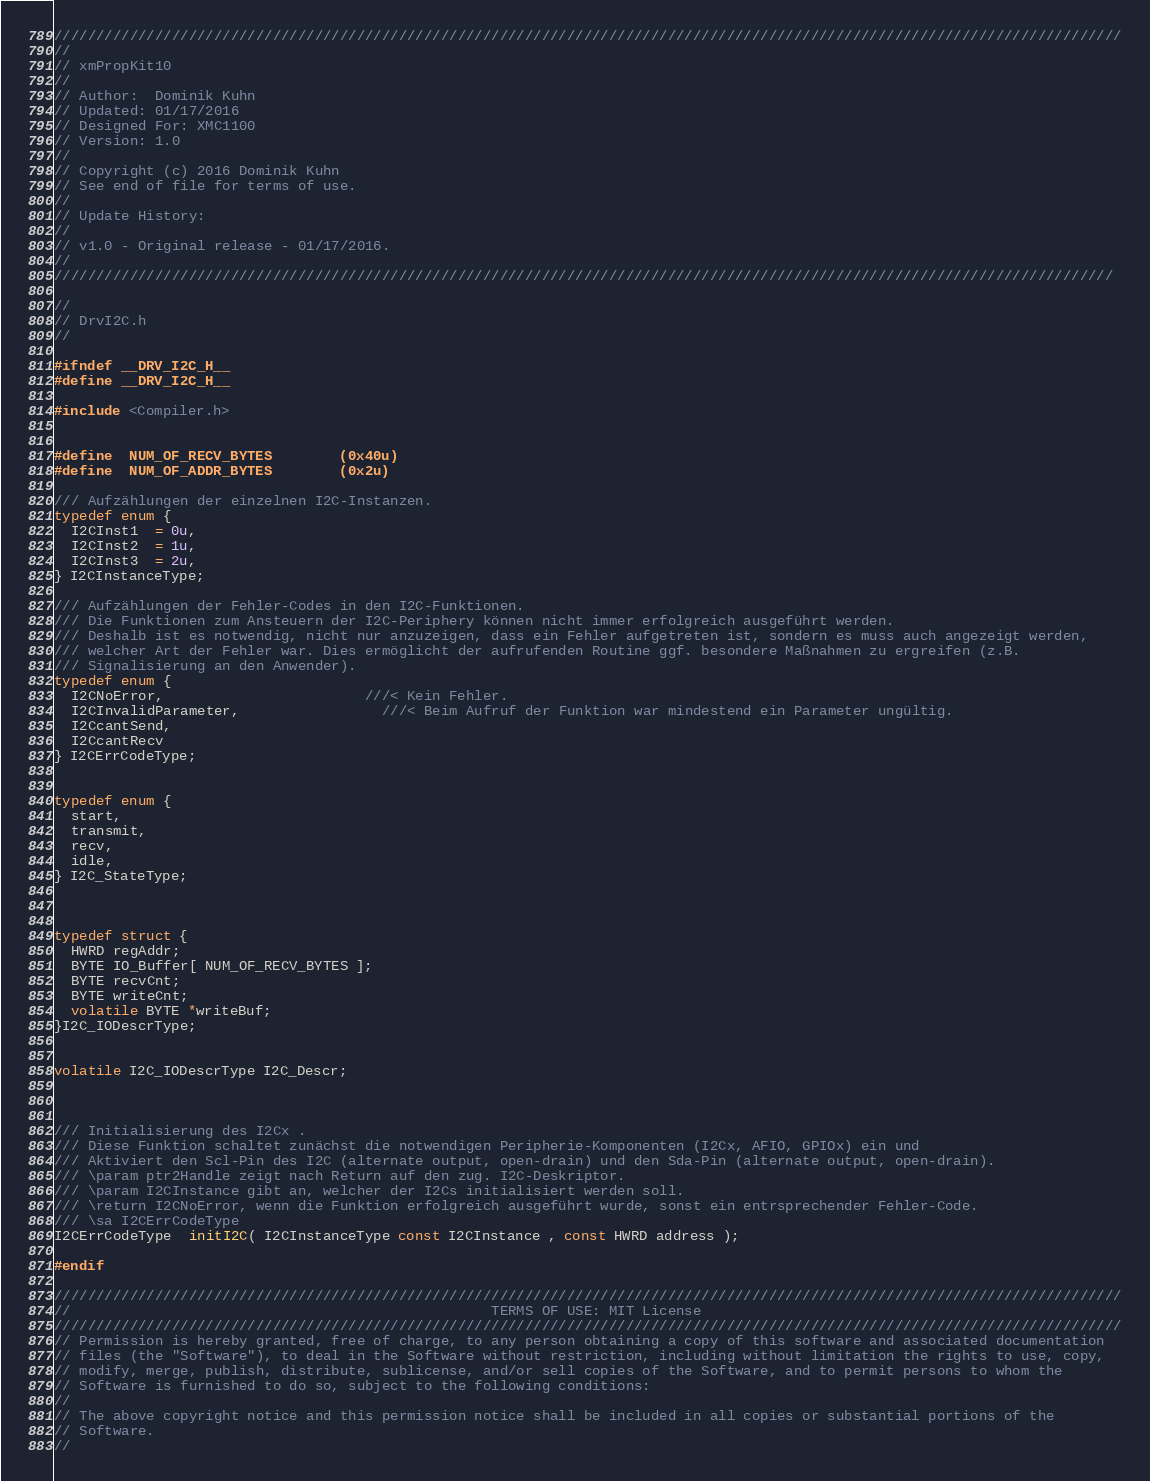<code> <loc_0><loc_0><loc_500><loc_500><_C_>///////////////////////////////////////////////////////////////////////////////////////////////////////////////////////////////
//
// xmPropKit10
//
// Author:  Dominik Kuhn
// Updated: 01/17/2016
// Designed For: XMC1100
// Version: 1.0
//
// Copyright (c) 2016 Dominik Kuhn
// See end of file for terms of use.
//
// Update History:
//
// v1.0 - Original release - 01/17/2016.
//
//////////////////////////////////////////////////////////////////////////////////////////////////////////////////////////////

//
// DrvI2C.h
//

#ifndef __DRV_I2C_H__
#define __DRV_I2C_H__

#include <Compiler.h>


#define  NUM_OF_RECV_BYTES        (0x40u)
#define  NUM_OF_ADDR_BYTES        (0x2u)

/// Aufzählungen der einzelnen I2C-Instanzen.
typedef enum {
  I2CInst1  = 0u,
  I2CInst2  = 1u,
  I2CInst3  = 2u,
} I2CInstanceType;

/// Aufzählungen der Fehler-Codes in den I2C-Funktionen.
/// Die Funktionen zum Ansteuern der I2C-Periphery können nicht immer erfolgreich ausgeführt werden. 
/// Deshalb ist es notwendig, nicht nur anzuzeigen, dass ein Fehler aufgetreten ist, sondern es muss auch angezeigt werden,
/// welcher Art der Fehler war. Dies ermöglicht der aufrufenden Routine ggf. besondere Maßnahmen zu ergreifen (z.B. 
/// Signalisierung an den Anwender).
typedef enum {
  I2CNoError,                        ///< Kein Fehler.
  I2CInvalidParameter,	             ///< Beim Aufruf der Funktion war mindestend ein Parameter ungültig.
  I2CcantSend,
  I2CcantRecv
} I2CErrCodeType;


typedef enum {
  start,
  transmit,
  recv,
  idle,
} I2C_StateType;



typedef struct {
  HWRD regAddr;
  BYTE IO_Buffer[ NUM_OF_RECV_BYTES ];
  BYTE recvCnt;
  BYTE writeCnt;  
  volatile BYTE *writeBuf;
}I2C_IODescrType;


volatile I2C_IODescrType I2C_Descr;



/// Initialisierung des I2Cx .
/// Diese Funktion schaltet zunächst die notwendigen Peripherie-Komponenten (I2Cx, AFIO, GPIOx) ein und
/// Aktiviert den Scl-Pin des I2C (alternate output, open-drain) und den Sda-Pin (alternate output, open-drain).
/// \param ptr2Handle zeigt nach Return auf den zug. I2C-Deskriptor.
/// \param I2CInstance gibt an, welcher der I2Cs initialisiert werden soll.
/// \return I2CNoError, wenn die Funktion erfolgreich ausgeführt wurde, sonst ein entrsprechender Fehler-Code.
/// \sa I2CErrCodeType
I2CErrCodeType  initI2C( I2CInstanceType const I2CInstance , const HWRD address );

#endif

///////////////////////////////////////////////////////////////////////////////////////////////////////////////////////////////
//                                                  TERMS OF USE: MIT License
///////////////////////////////////////////////////////////////////////////////////////////////////////////////////////////////
// Permission is hereby granted, free of charge, to any person obtaining a copy of this software and associated documentation
// files (the "Software"), to deal in the Software without restriction, including without limitation the rights to use, copy,
// modify, merge, publish, distribute, sublicense, and/or sell copies of the Software, and to permit persons to whom the
// Software is furnished to do so, subject to the following conditions:
//
// The above copyright notice and this permission notice shall be included in all copies or substantial portions of the
// Software.
//</code> 